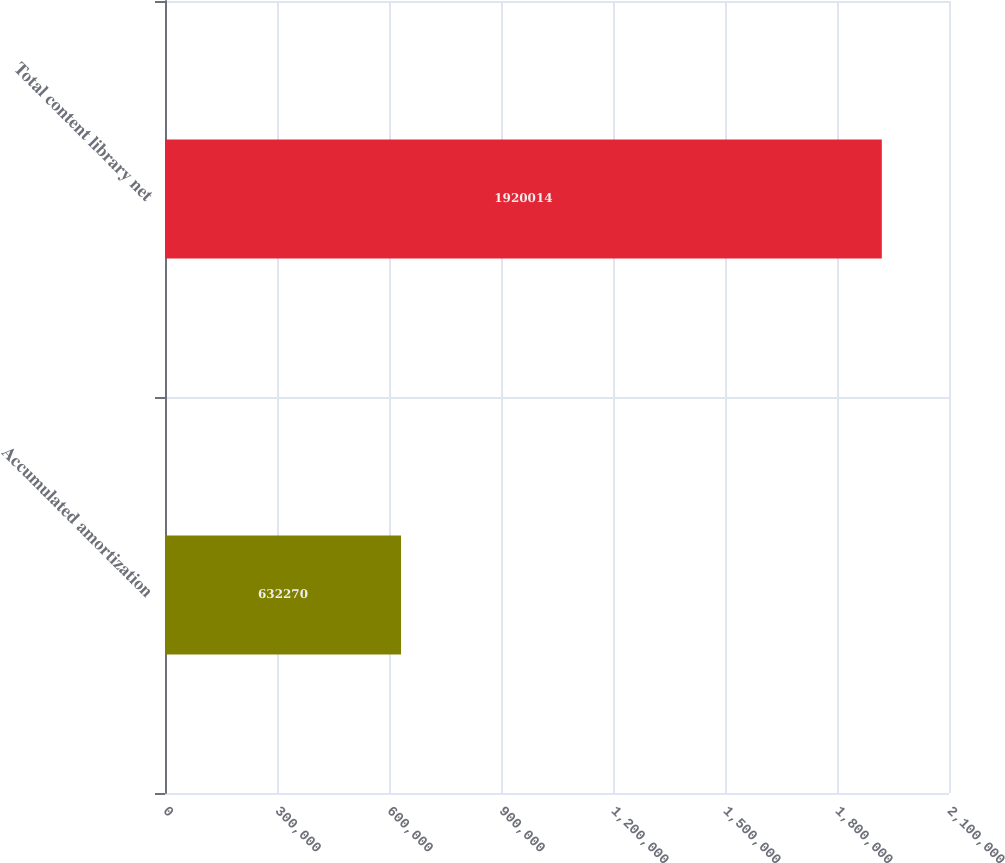<chart> <loc_0><loc_0><loc_500><loc_500><bar_chart><fcel>Accumulated amortization<fcel>Total content library net<nl><fcel>632270<fcel>1.92001e+06<nl></chart> 